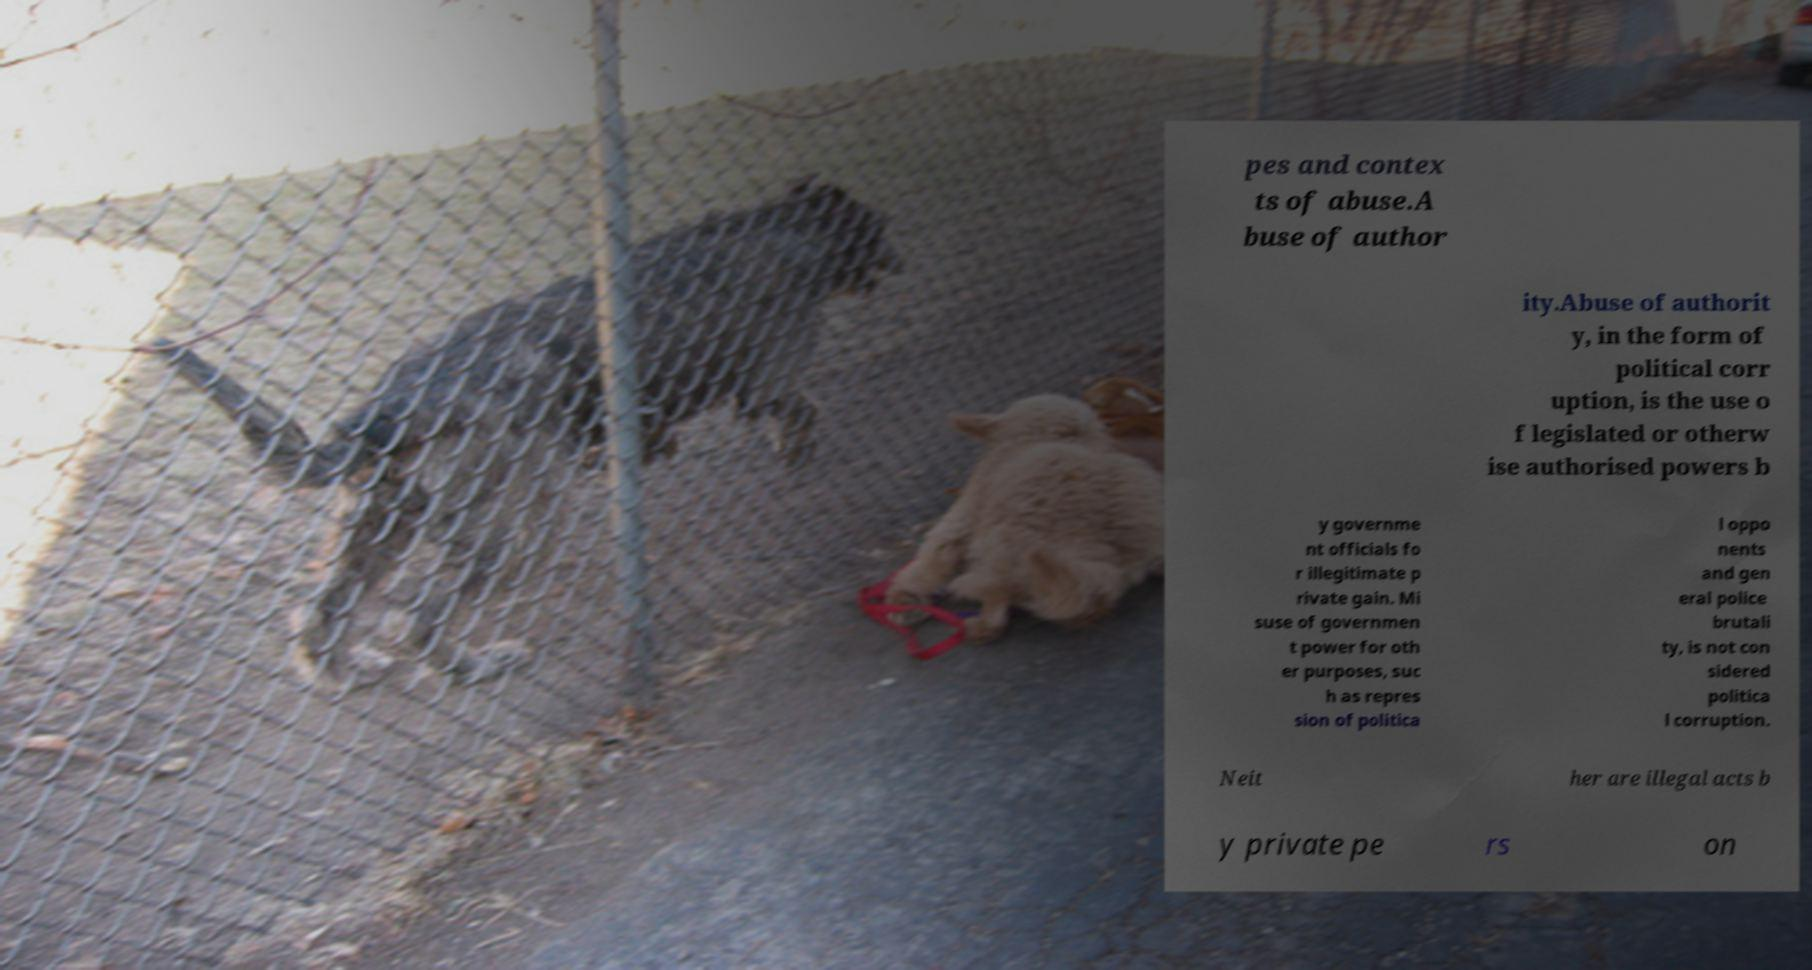Could you assist in decoding the text presented in this image and type it out clearly? pes and contex ts of abuse.A buse of author ity.Abuse of authorit y, in the form of political corr uption, is the use o f legislated or otherw ise authorised powers b y governme nt officials fo r illegitimate p rivate gain. Mi suse of governmen t power for oth er purposes, suc h as repres sion of politica l oppo nents and gen eral police brutali ty, is not con sidered politica l corruption. Neit her are illegal acts b y private pe rs on 